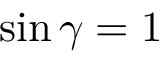<formula> <loc_0><loc_0><loc_500><loc_500>\sin \gamma = 1</formula> 